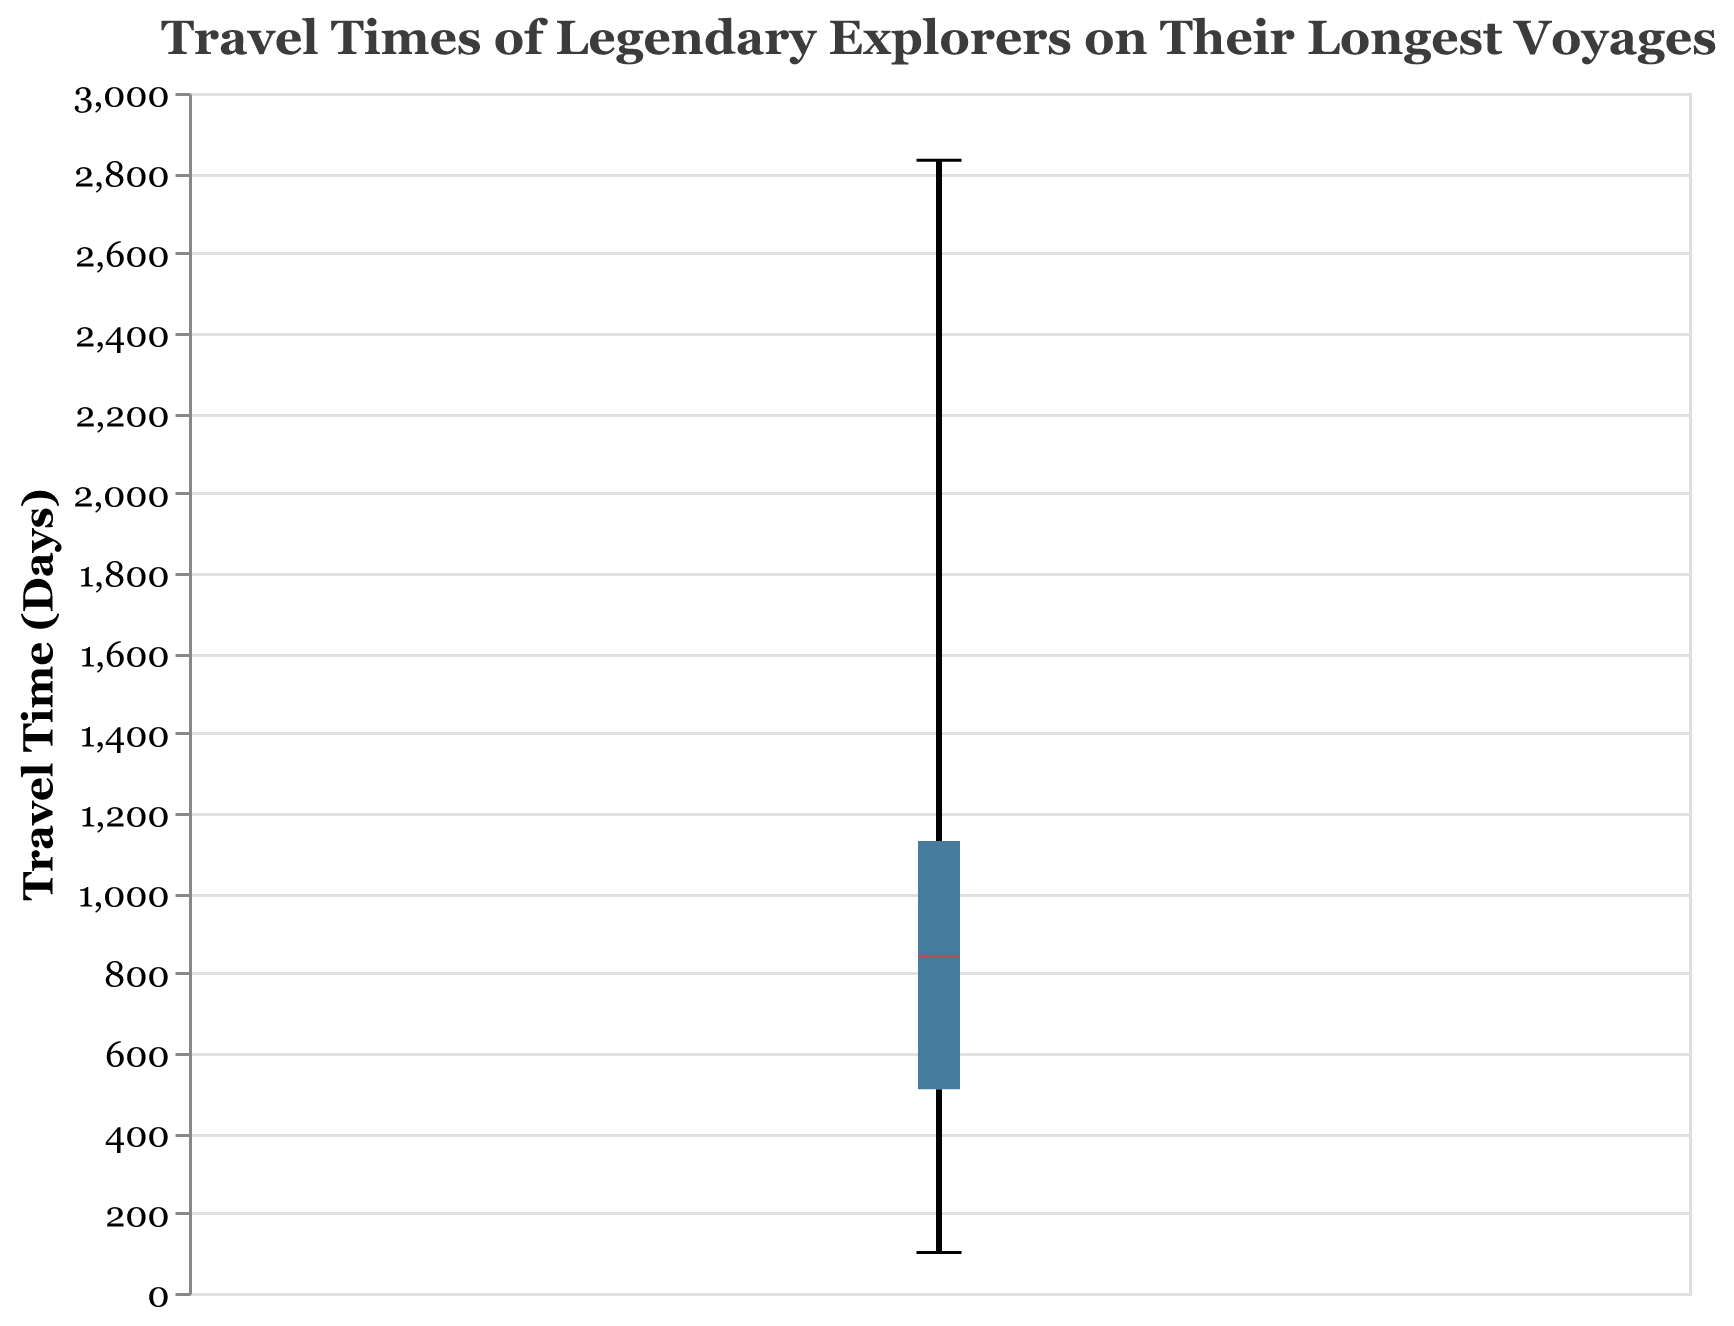What is the title of the figure? The title of the figure can be found at the top of the plot. It reads "Travel Times of Legendary Explorers on Their Longest Voyages," indicating the dataset being visualized.
Answer: Travel Times of Legendary Explorers on Their Longest Voyages What is the median travel time of the explorers? By examining the notched box plot, the median line inside the box represents the median travel time. The median line is highlighted in red.
Answer: Approximately 885 days Which explorer had the longest travel time? Observing the plot, the top whisker extends to the highest travel time value, which corresponds to the explorer with the longest travel time.
Answer: James Cook Which explorer had the shortest travel time? Looking at the bottom whisker of the plot, it extends to the lowest travel time value, representing the explorer with the shortest travel time.
Answer: Thor Heyerdahl What is the range of travel times observed in the plot? The range is the difference between the maximum and minimum travel times in the plot. The maximum value is the top whisker at approximately 2832 days, and the minimum value is the bottom whisker at around 101 days. So, the range is 2832 - 101.
Answer: 2731 days What is the interquartile range (IQR) of the explorers' travel times? The IQR is the range between the first quartile (Q1) and the third quartile (Q3) values, which are represented by the bottom and top edges of the box, respectively. Q1 is around 507 days, and Q3 is about 1165 days. The IQR is 1165 - 507.
Answer: 658 days Which explorer's travel time is closest to the 75th percentile? According to the plot, the third quartile (Q3) is at 1165 days. By checking the individual data points, the closest travel time to 1165 days belongs to Francis Drake.
Answer: Francis Drake How does Marco Polo's travel time compare to the median travel time? Marco Polo's travel time is 1095 days. The median travel time in the plot is around 885 days. Therefore, Marco Polo's travel time is higher than the median.
Answer: Higher Are there any outliers in the travel time data? Outliers in a box plot are typically indicated by individual points plotted outside the whiskers. In this plot, there are no such points evident, indicating the absence of outliers.
Answer: No What is the typical travel time range for most explorers? The typical range for travel times in a box plot is between the first quartile (Q1) and the third quartile (Q3), which are represented by the bottom and top edges of the box, respectively. This range is from approximately 507 to 1165 days.
Answer: Approximately 507 to 1165 days 